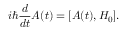<formula> <loc_0><loc_0><loc_500><loc_500>i \hbar { \frac { d } { d t } } A ( t ) = [ A ( t ) , H _ { 0 } ] .</formula> 